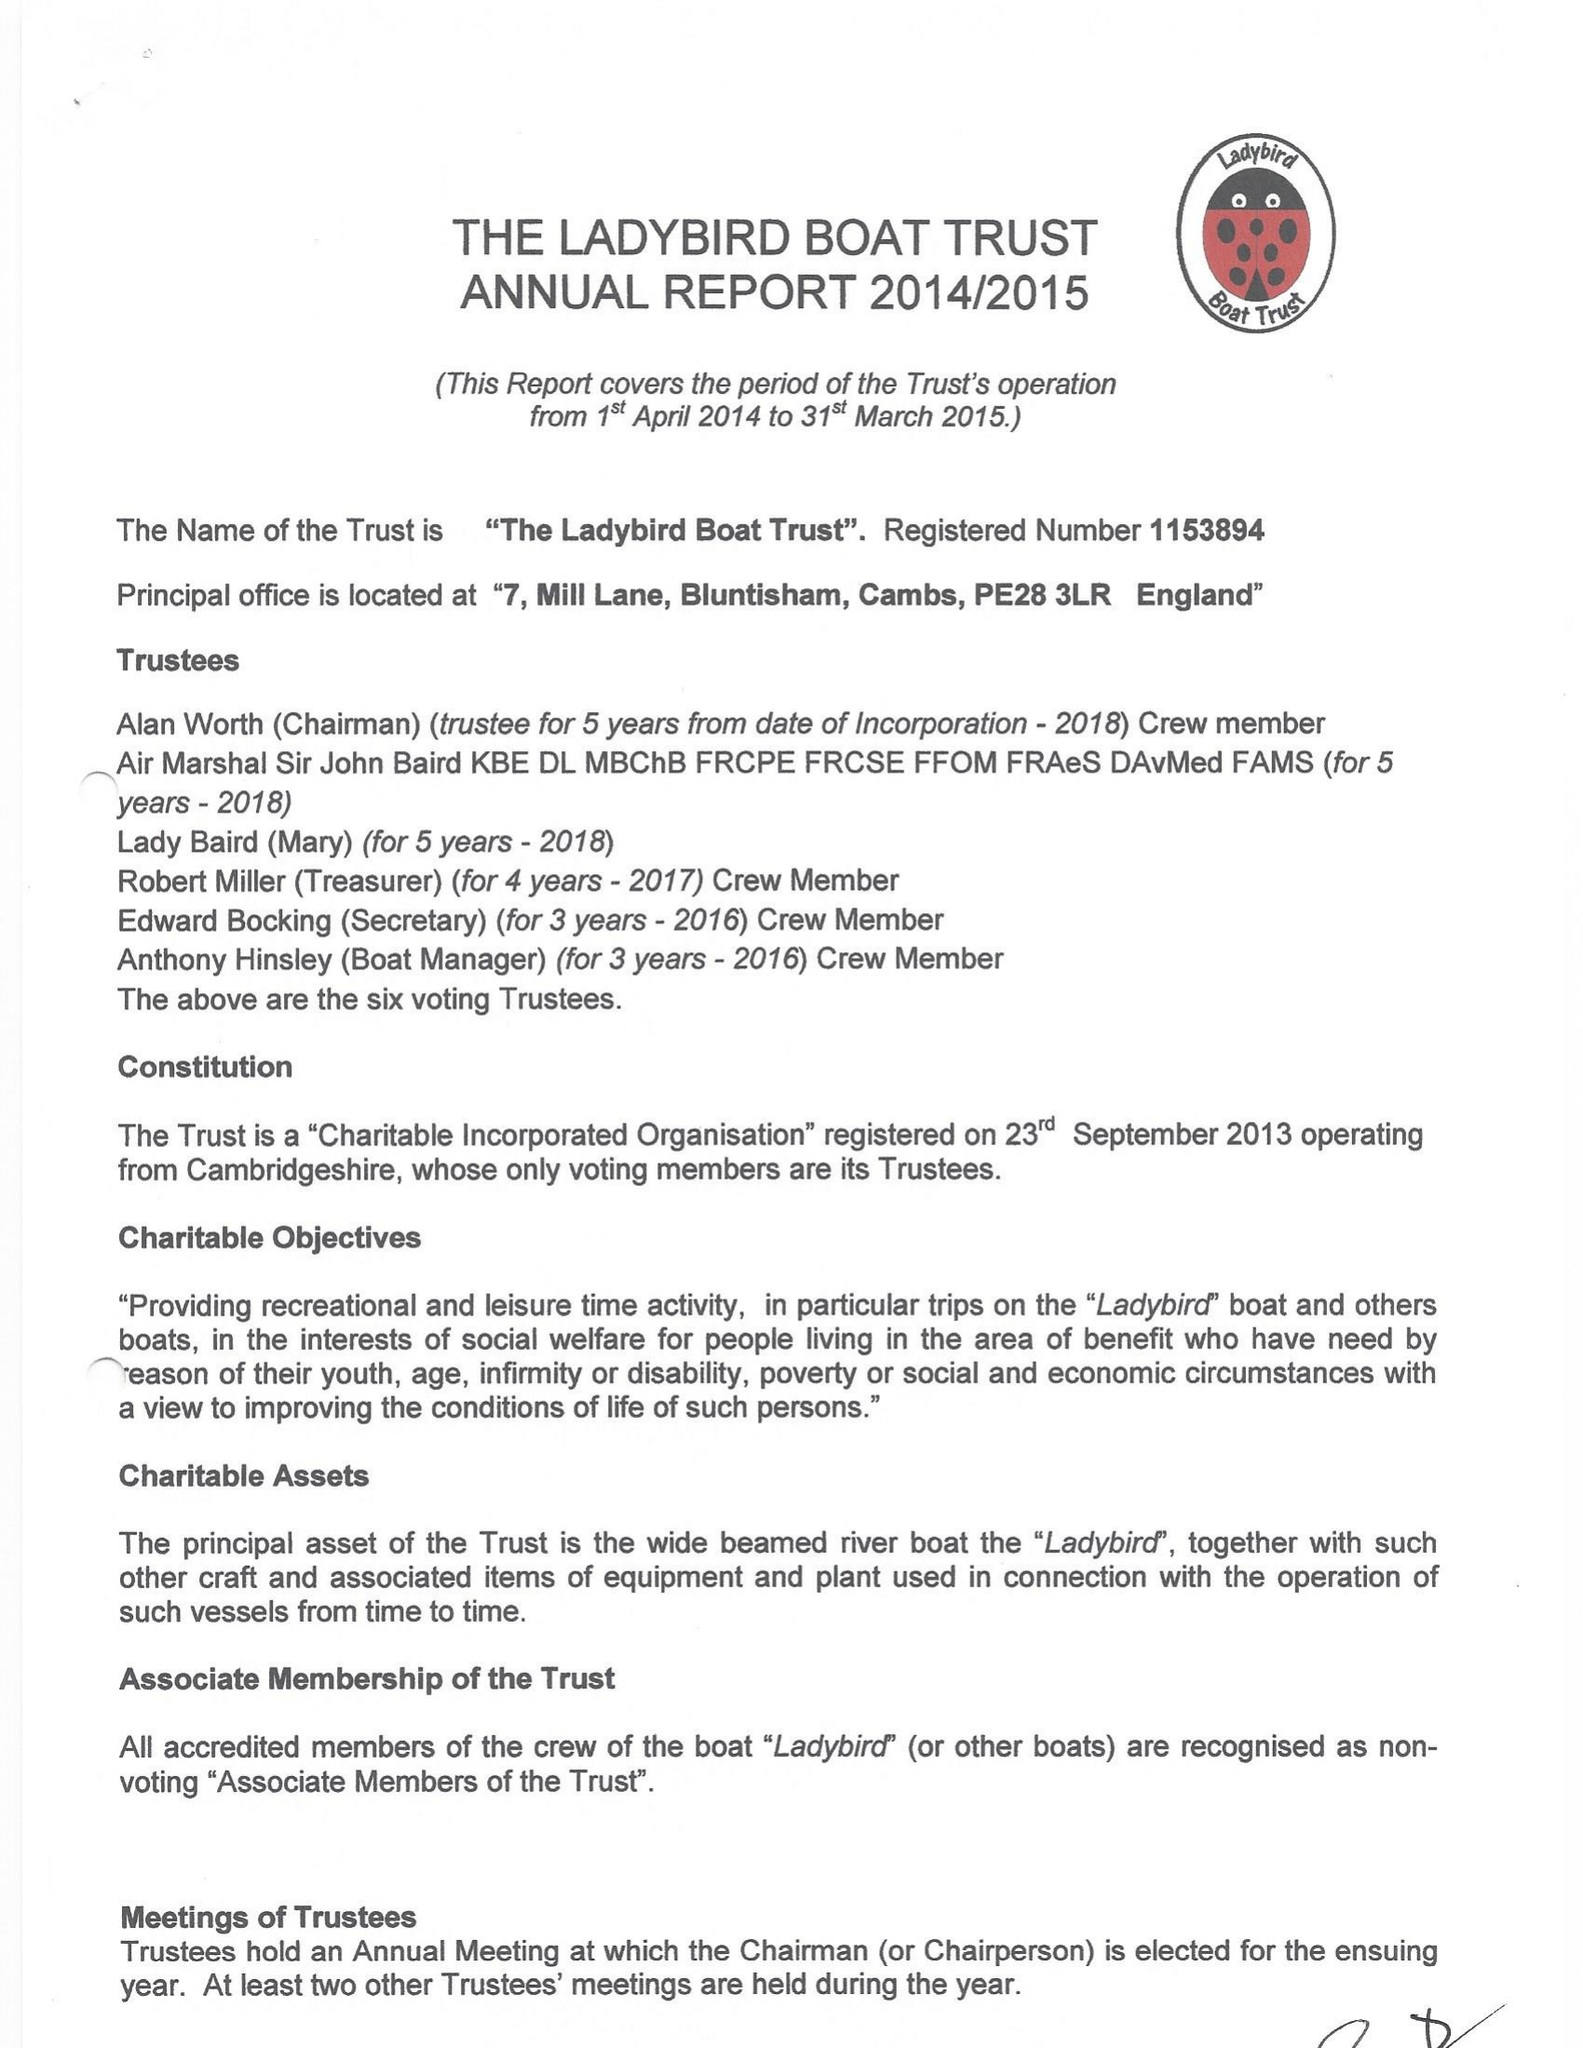What is the value for the spending_annually_in_british_pounds?
Answer the question using a single word or phrase. 13067.00 